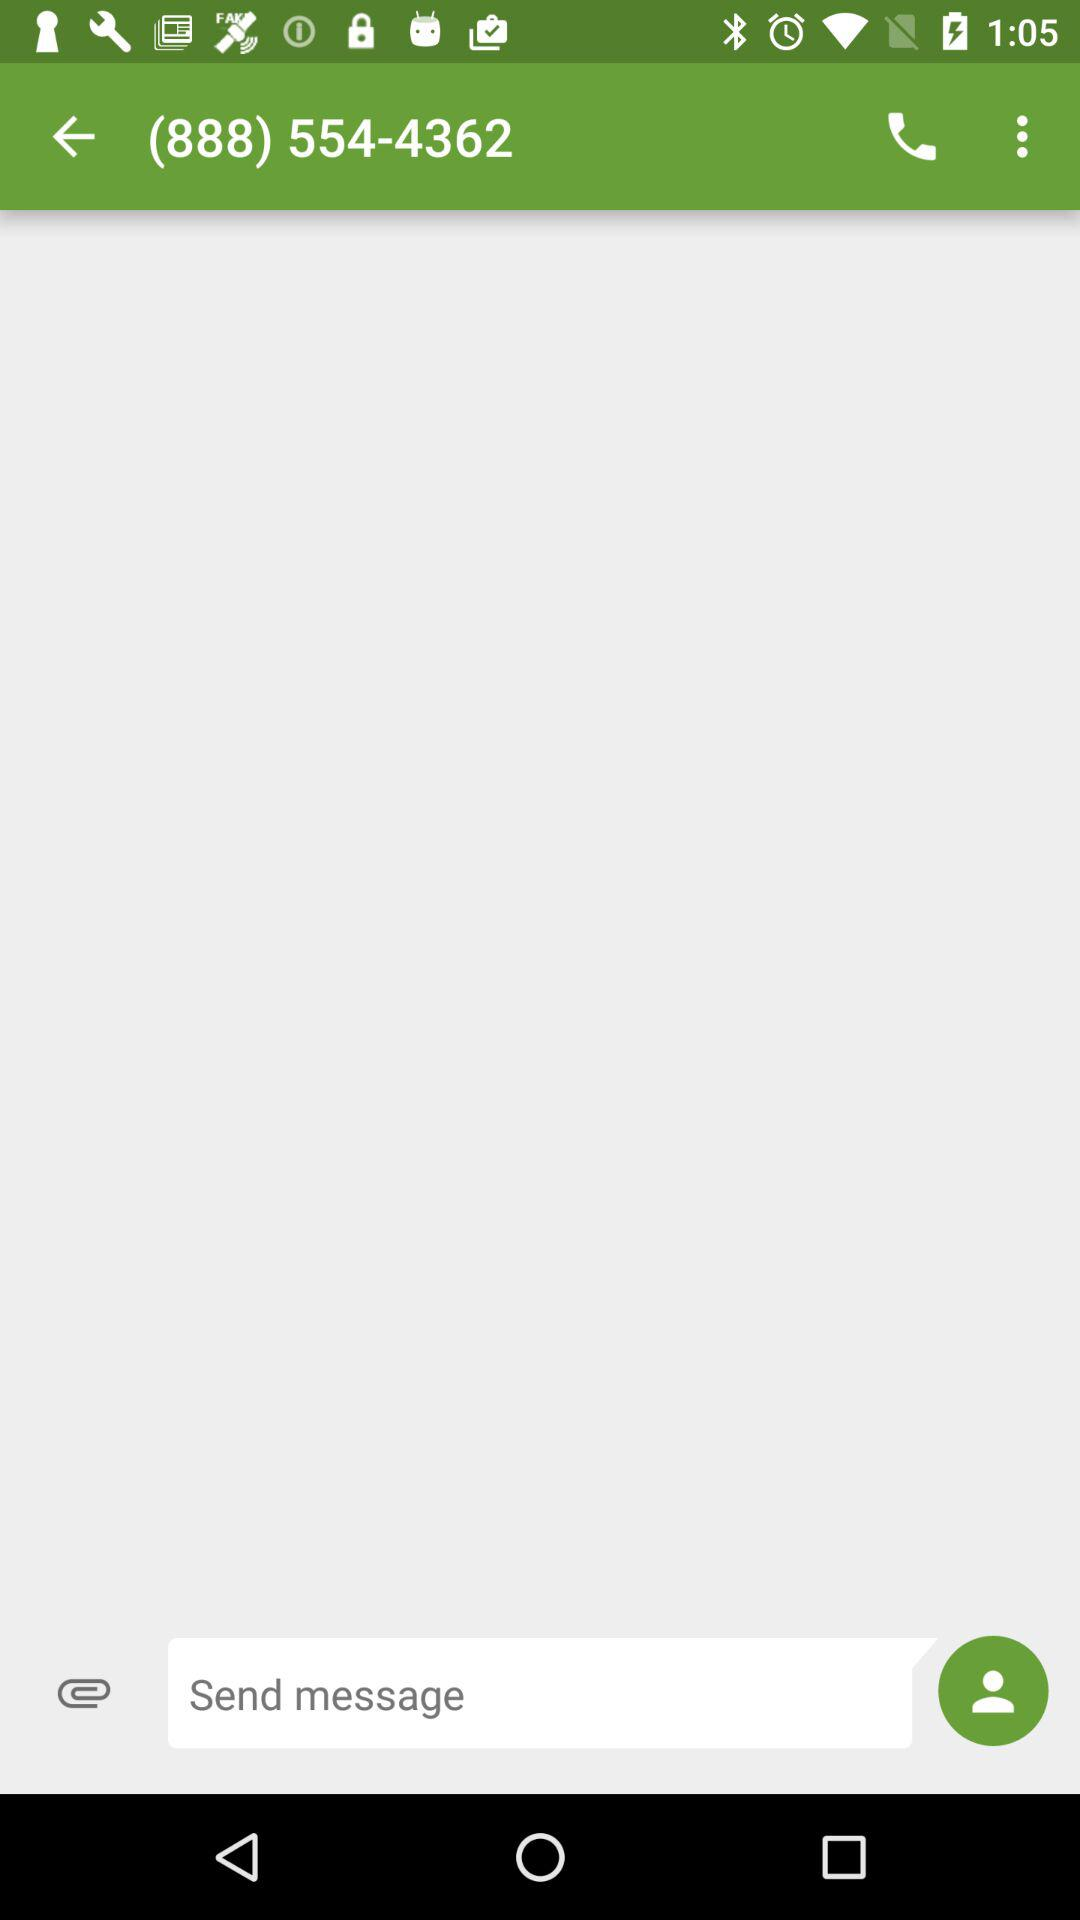What is the contact number? The contact number is (888) 554-4362. 